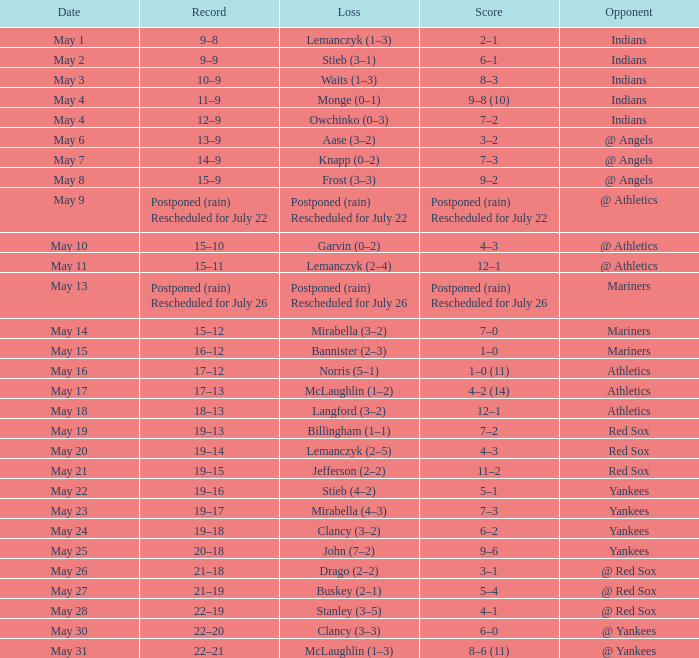Name the loss on may 22 Stieb (4–2). 